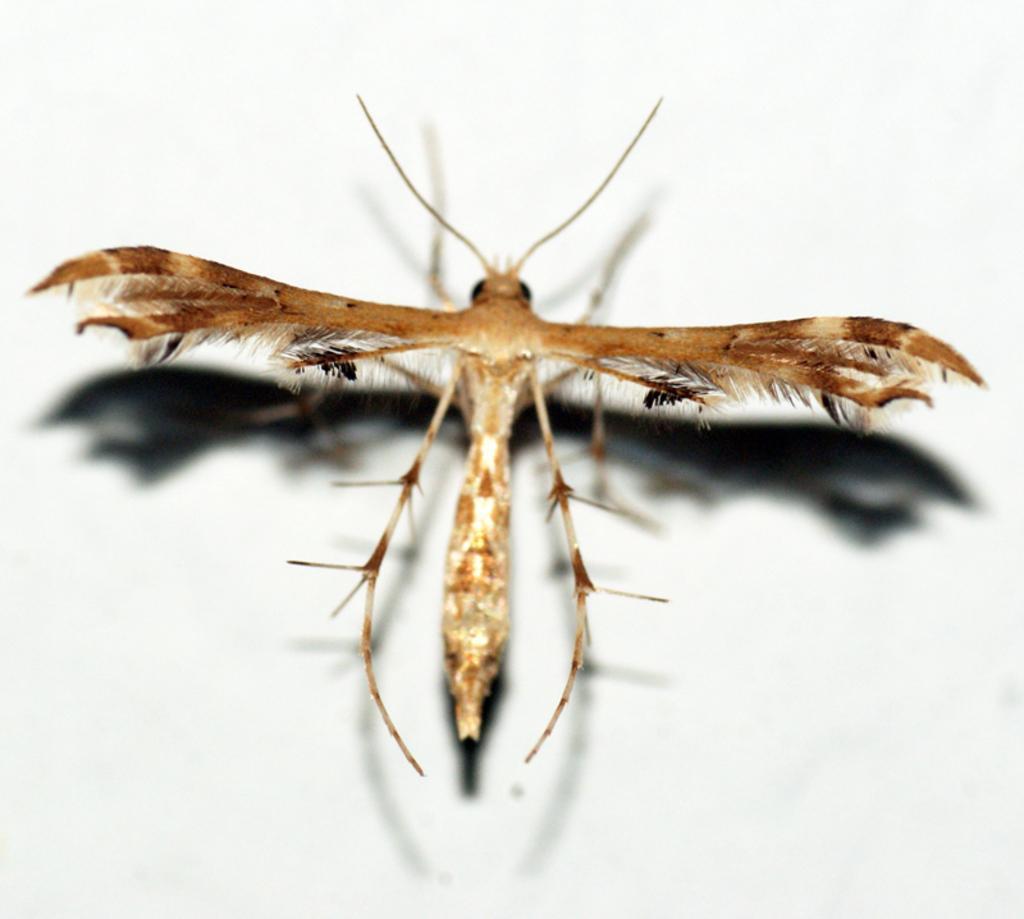Describe this image in one or two sentences. In the picture we can see an insect with wings and a long antenna and it is standing on the wall, the insect is brown in color with some white shades on it. 